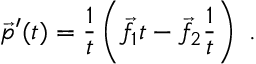Convert formula to latex. <formula><loc_0><loc_0><loc_500><loc_500>{ \vec { p } } ^ { \prime } ( t ) = { \frac { 1 } { t } } \left ( { \vec { f } } _ { 1 } t - { \vec { f } } _ { 2 } { \frac { 1 } { t } } \right ) \ .</formula> 